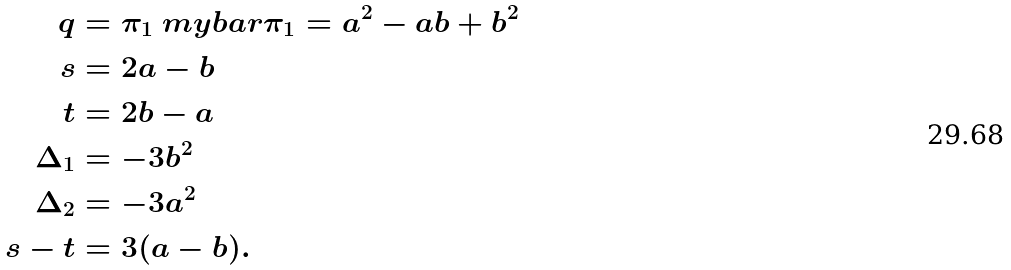Convert formula to latex. <formula><loc_0><loc_0><loc_500><loc_500>q & = \pi _ { 1 } \ m y b a r { \pi _ { 1 } } = a ^ { 2 } - a b + b ^ { 2 } \\ s & = 2 a - b \\ t & = 2 b - a \\ \Delta _ { 1 } & = - 3 b ^ { 2 } \\ \Delta _ { 2 } & = - 3 a ^ { 2 } \\ s - t & = 3 ( a - b ) .</formula> 